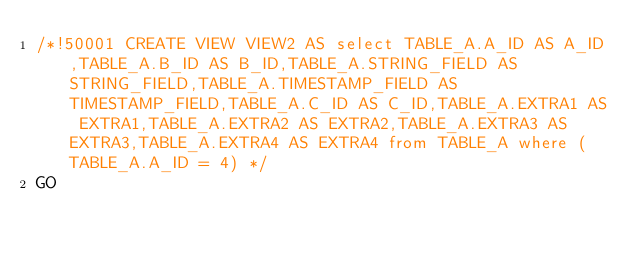Convert code to text. <code><loc_0><loc_0><loc_500><loc_500><_SQL_>/*!50001 CREATE VIEW VIEW2 AS select TABLE_A.A_ID AS A_ID,TABLE_A.B_ID AS B_ID,TABLE_A.STRING_FIELD AS STRING_FIELD,TABLE_A.TIMESTAMP_FIELD AS TIMESTAMP_FIELD,TABLE_A.C_ID AS C_ID,TABLE_A.EXTRA1 AS EXTRA1,TABLE_A.EXTRA2 AS EXTRA2,TABLE_A.EXTRA3 AS EXTRA3,TABLE_A.EXTRA4 AS EXTRA4 from TABLE_A where (TABLE_A.A_ID = 4) */
GO</code> 